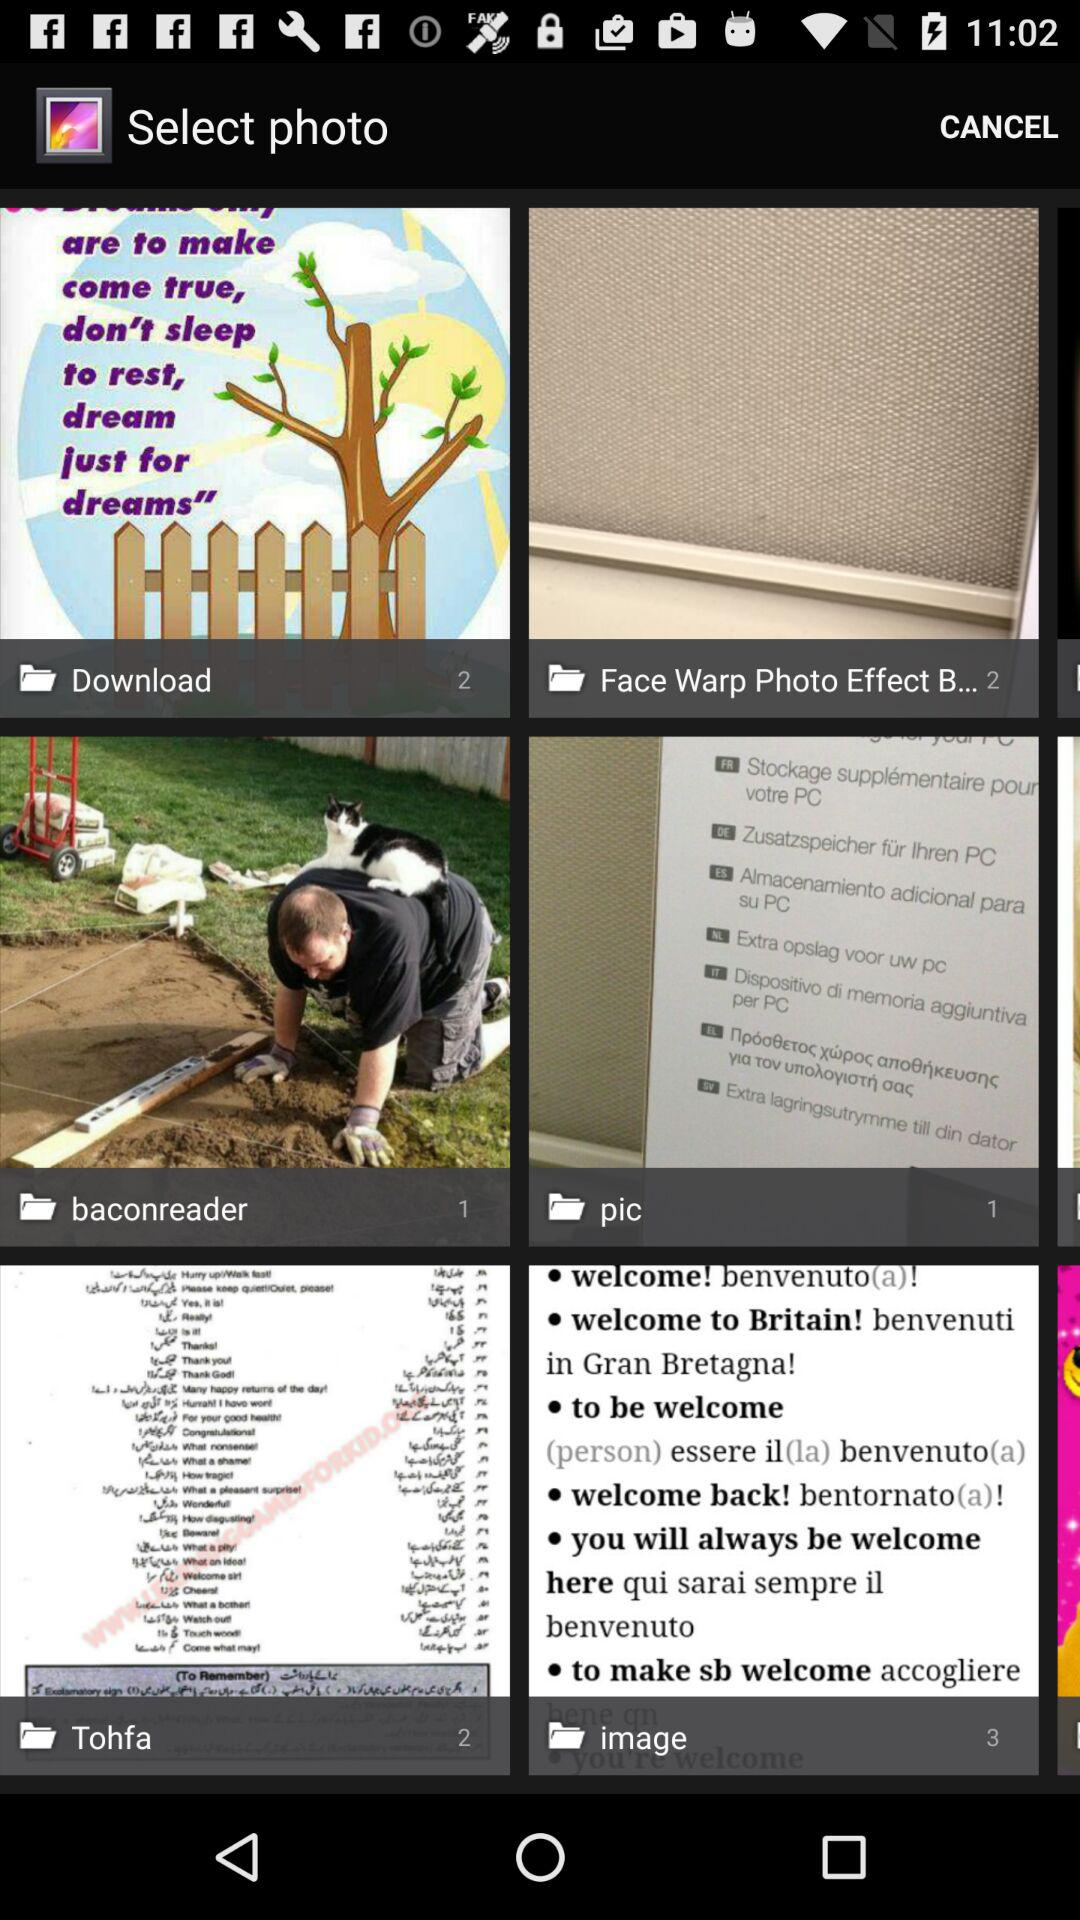How many photos are in "Download"? There are 2 photos. 